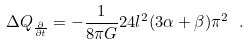Convert formula to latex. <formula><loc_0><loc_0><loc_500><loc_500>\Delta Q _ { \frac { \partial } { \partial t } } = - \frac { 1 } { 8 \pi G } 2 4 l ^ { 2 } ( 3 \alpha + \beta ) \pi ^ { 2 } \ .</formula> 